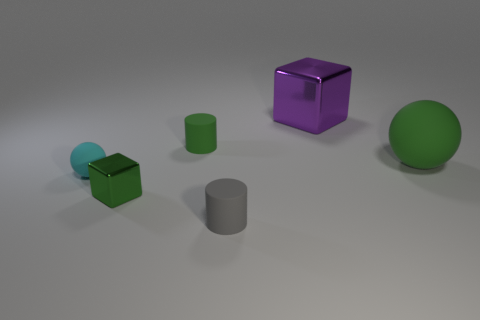How many green things are small things or small metallic things?
Provide a succinct answer. 2. Does the matte thing on the right side of the purple object have the same color as the tiny shiny object?
Your answer should be compact. Yes. What size is the matte sphere that is left of the block behind the small cube?
Your answer should be compact. Small. What material is the cube that is the same size as the gray cylinder?
Keep it short and to the point. Metal. What number of other objects are there of the same size as the green ball?
Your response must be concise. 1. What number of cylinders are small shiny objects or gray matte objects?
Provide a succinct answer. 1. The cube that is on the left side of the metal cube behind the metallic block to the left of the big metallic thing is made of what material?
Make the answer very short. Metal. What is the material of the small cube that is the same color as the big rubber sphere?
Keep it short and to the point. Metal. What number of small cylinders are made of the same material as the large green ball?
Offer a very short reply. 2. Does the metal object that is behind the cyan ball have the same size as the large green thing?
Your answer should be compact. Yes. 